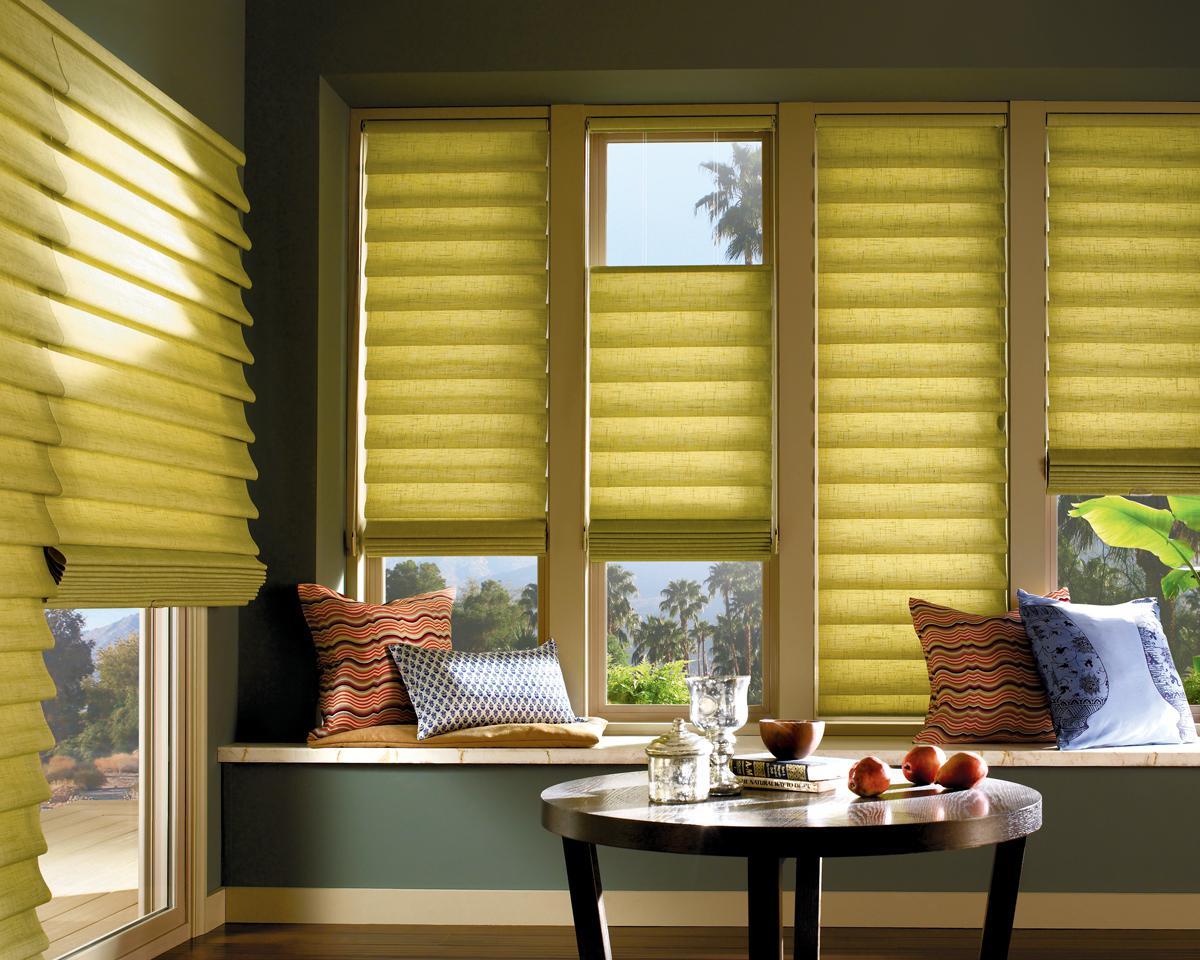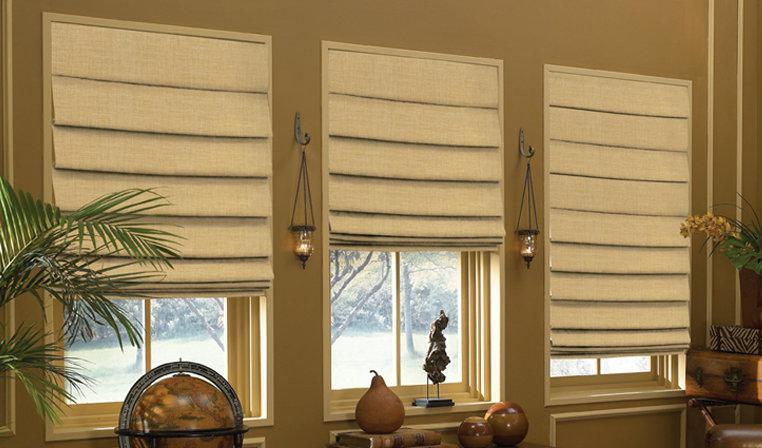The first image is the image on the left, the second image is the image on the right. Analyze the images presented: Is the assertion "One of the images shows windows and curtains with no surrounding room." valid? Answer yes or no. No. The first image is the image on the left, the second image is the image on the right. Evaluate the accuracy of this statement regarding the images: "The left and right image contains the same number of blinds.". Is it true? Answer yes or no. No. 